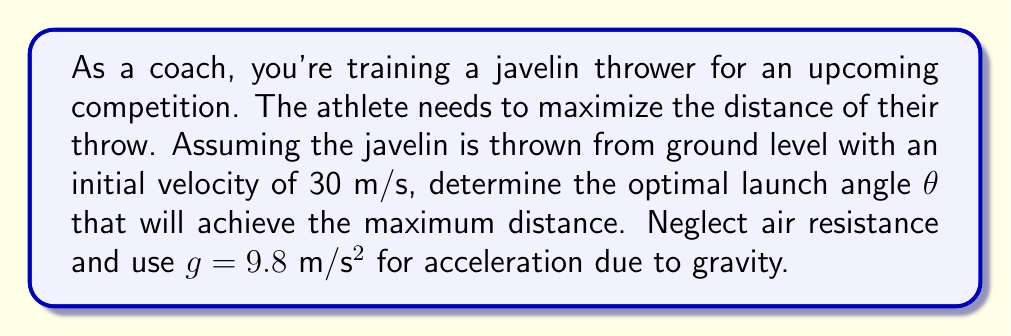Show me your answer to this math problem. To solve this problem, we need to use the equations of projectile motion and optimize for maximum distance. Let's approach this step-by-step:

1) The range (R) of a projectile launched from ground level is given by:

   $$R = \frac{v_0^2 \sin(2\theta)}{g}$$

   where $v_0$ is the initial velocity, θ is the launch angle, and g is the acceleration due to gravity.

2) To find the maximum range, we need to maximize $\sin(2\theta)$. The maximum value of sine is 1, which occurs when its argument is 90°.

3) Therefore, $2\theta = 90°$, or $\theta = 45°$.

4) We can verify this mathematically by taking the derivative of R with respect to θ and setting it to zero:

   $$\frac{dR}{d\theta} = \frac{v_0^2}{g} \cdot 2\cos(2\theta) = 0$$

   This is true when $\cos(2\theta) = 0$, which occurs when $2\theta = 90°$ or $\theta = 45°$.

5) To calculate the maximum distance:

   $$R_{max} = \frac{v_0^2 \sin(2 \cdot 45°)}{g} = \frac{(30 \text{ m/s})^2 \cdot 1}{9.8 \text{ m/s}^2} = 91.84 \text{ m}$$

This result shows that the optimal angle for maximum distance is always 45° when launching from ground level, regardless of the initial velocity (assuming no air resistance).
Answer: The optimal launch angle θ for maximum distance is 45°, resulting in a maximum throw distance of 91.84 meters. 